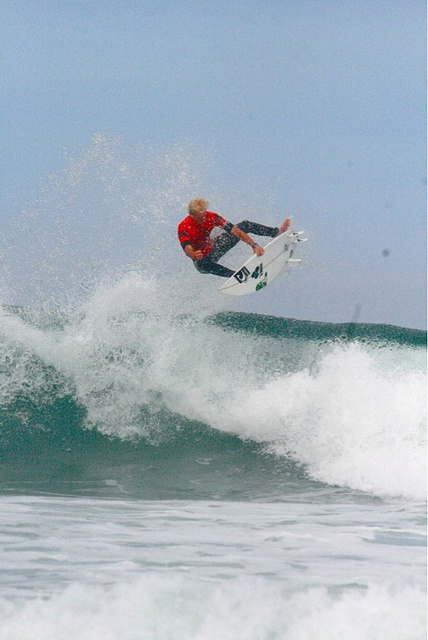Describe the objects in this image and their specific colors. I can see people in lightblue, black, maroon, gray, and darkgray tones and surfboard in lightblue, darkgray, lightgray, gray, and black tones in this image. 